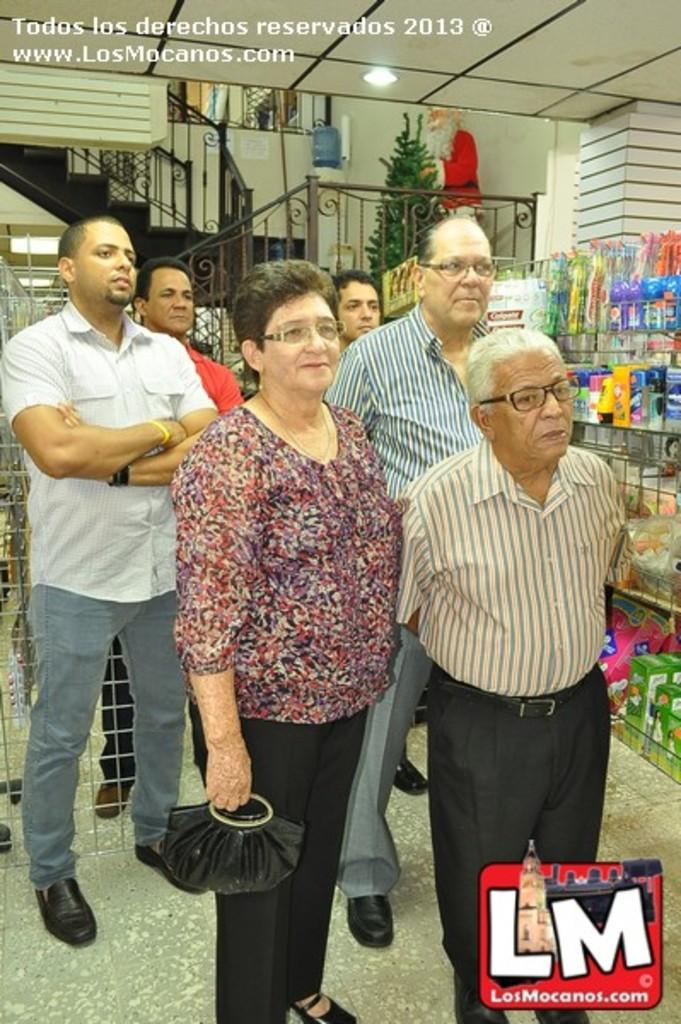What are the people in the image doing? The persons standing on the floor are likely engaged in some activity or standing in a particular area. What can be seen hanging or mounted on the wall? There is a rack in the image, which may be used for hanging or storing items. What type of containers are visible in the image? There are bottles and boxes in the image, which may contain various items or substances. What is the source of illumination in the image? There is a light in the image, which provides visibility and brightness. What type of greenery is present in the image? There is a plant in the image, which adds a natural element to the scene. What architectural feature is present in the image? There is a staircase in the image, which allows for movement between different levels. What structural element is present in the image? There is a pillar in the image, which provides support and stability to the surrounding structure. What can be seen in the background of the image? There is a wall in the background of the image, which serves as a boundary or backdrop for the scene. How many cows are present in the image? There are no cows present in the image. What type of example can be seen in the image? There is no specific example depicted in the image; it contains various objects and people. 